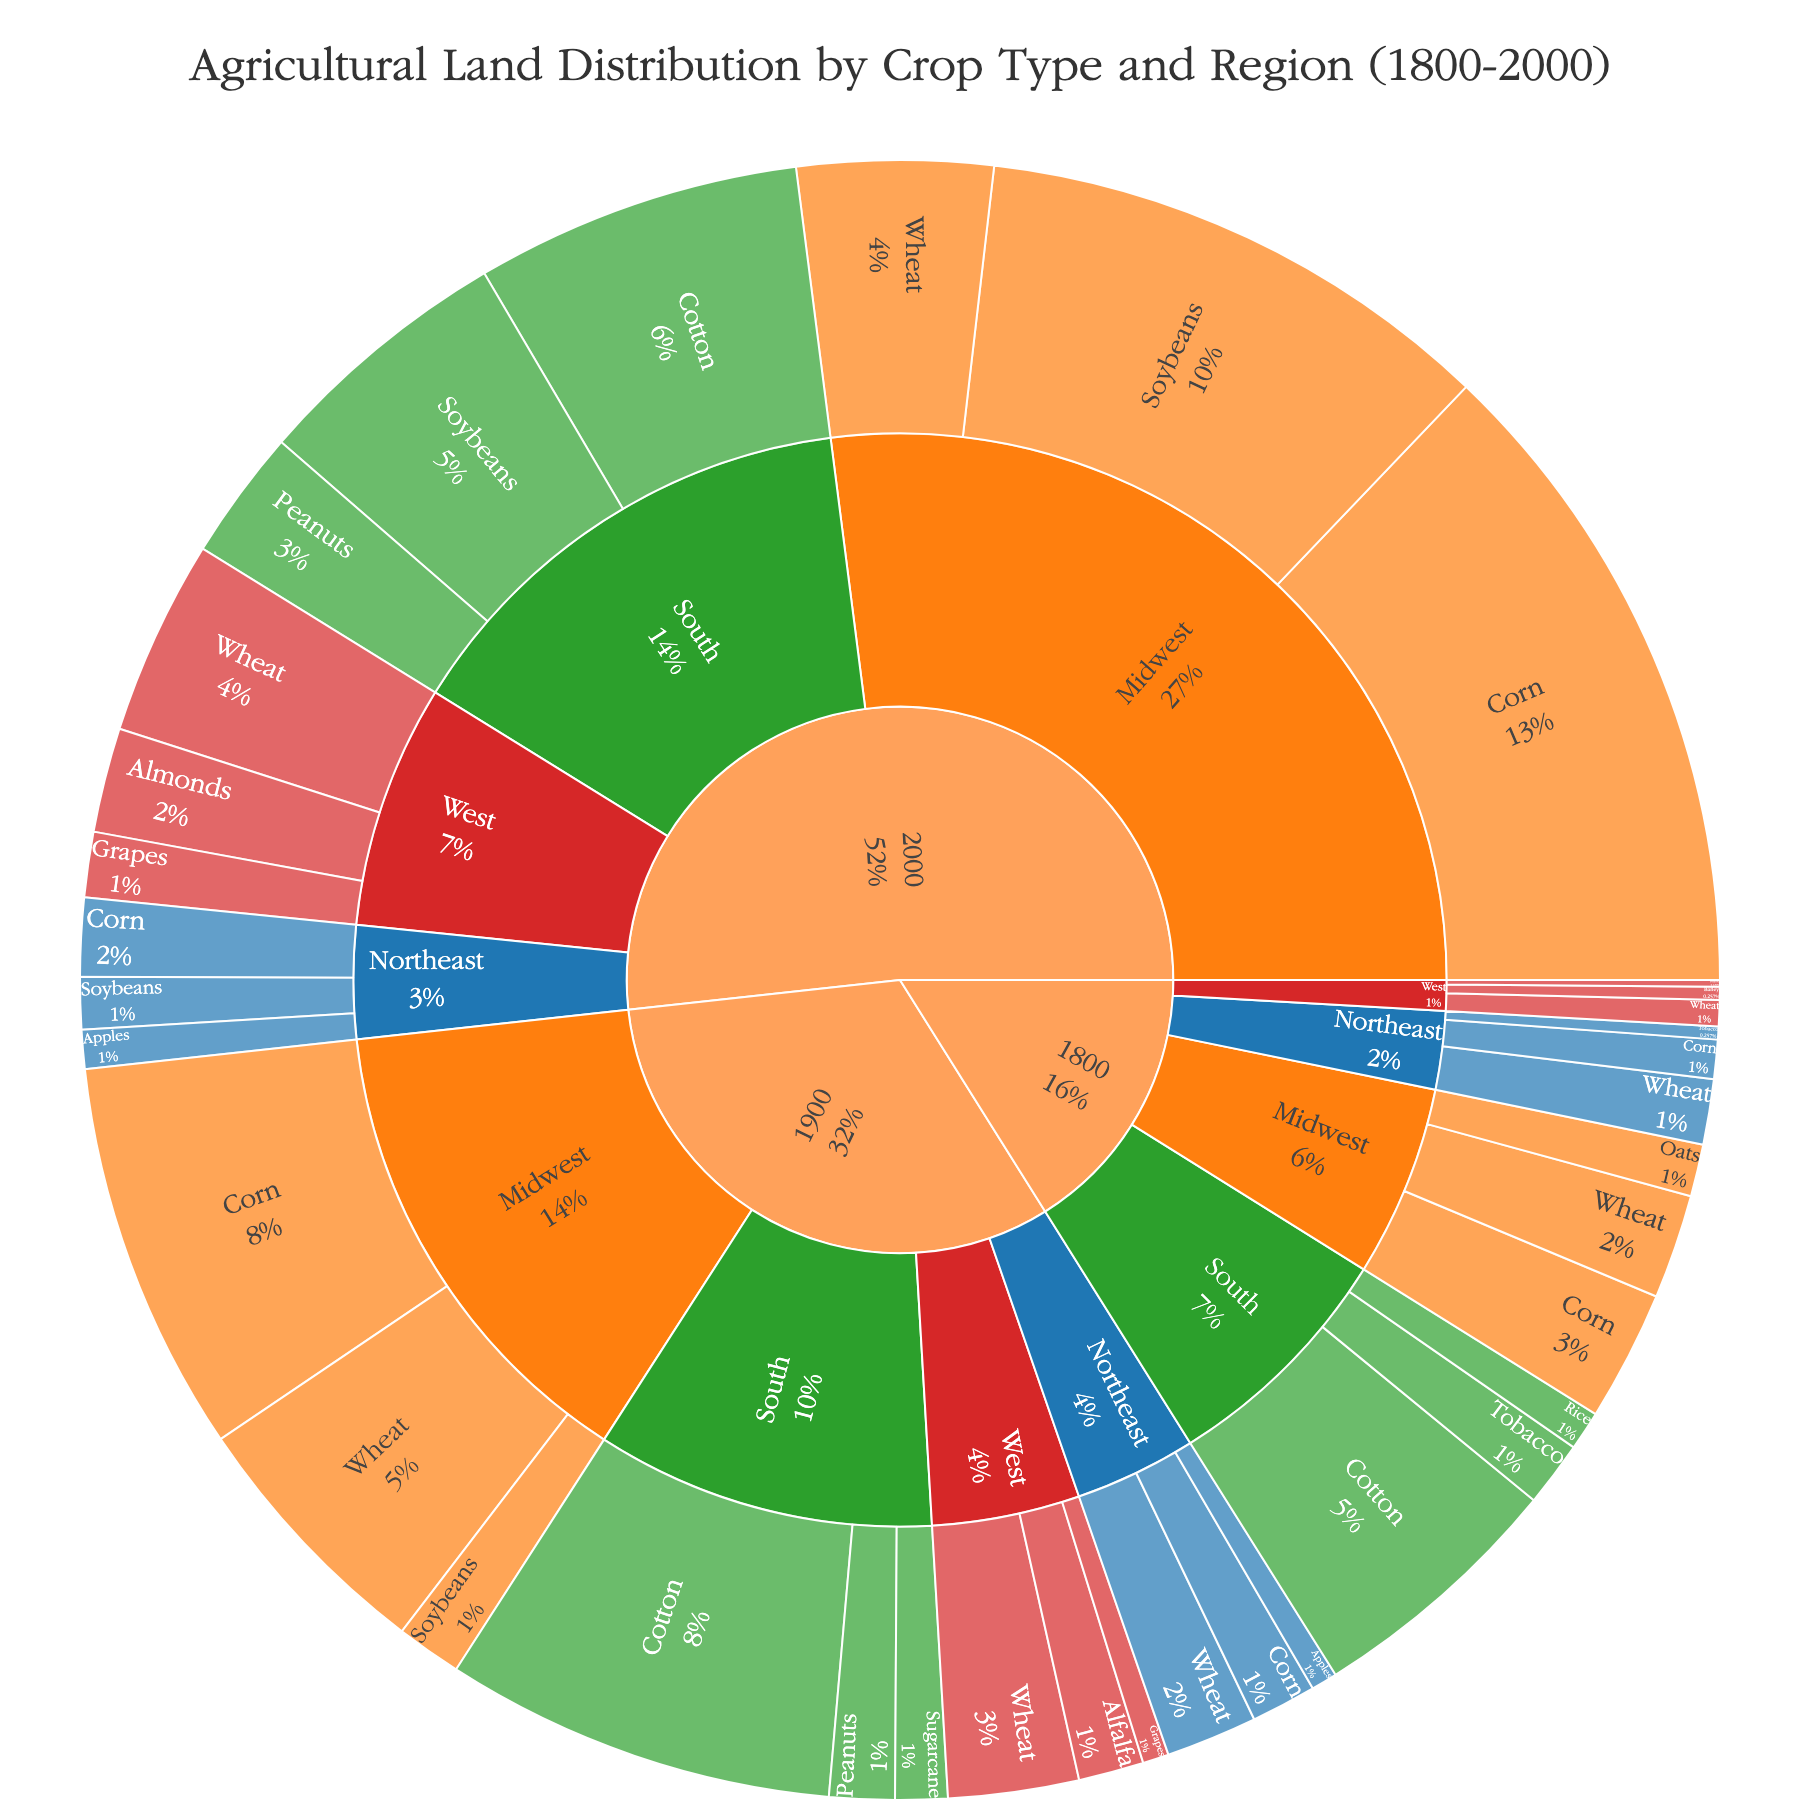What is the title of the figure? The title of the figure is usually presented at the top. In this case, it is "Agricultural Land Distribution by Crop Type and Region (1800-2000)."
Answer: Agricultural Land Distribution by Crop Type and Region (1800-2000) What colors are used to differentiate the regions? The regions are color-coded for distinction. Northeast is blue, Midwest is orange, South is green, and West is red.
Answer: Blue, Orange, Green, Red Which crop has the most significant increase in acreage in the Midwest from 1800 to 2000? To find the crop with the most significant increase, examine the acreage for each crop in the Midwest for 1800 and 2000. Corn goes from 1,000,000 acres in 1800 to 5,000,000 acres in 2000.
Answer: Corn In the year 1900, which region has the highest total acreage? Sum the acreages for each region in 1900. The South has Cotton (3,000,000), Peanuts (500,000), and Sugarcane (400,000), totaling 3,900,000 acres, which is the highest among the regions.
Answer: South Which region in the year 2000 has more acres dedicated to Soybeans? Compare the Soybeans acreage in 2000 across the regions. Midwest has 4,000,000 acres, South has 2,000,000 acres, and Northeast has 400,000 acres. The Midwest has the highest with 4,000,000 acres.
Answer: Midwest What is the total acreage of wheat in the West over all years? Sum the wheat acreages in the West for 1800 (200,000), 1900 (1,000,000), and 2000 (1,500,000), which totals 2,700,000 acres.
Answer: 2,700,000 acres Compare the acreage of Cotton in the South between 1800 and 2000. To compare, note Cotton in the South is 2,000,000 acres in 1800 and 2,500,000 acres in 2000. The acreage has increased by 500,000 acres.
Answer: 500,000 acres increase Which crop occupies the smallest acreage in the Northeast in 1900? Check the acreages for each crop in the Northeast in 1900: Wheat (700,000), Corn (500,000), and Apples (200,000). Apples occupy the smallest acreage.
Answer: Apples How does the land distribution for Corn in the Northeast change from 1800 to 2000? For Corn in the Northeast, the acreage changes from 300,000 in 1800 to 600,000 in 2000, indicating a doubling in land use for Corn.
Answer: Doubled Which year shows the greatest diversity in crop types across all regions? Look at the variety of crops in each year. In 2000, there are multiple crops in each region, showing the greatest diversity: Corn, Wheat, Soybeans, Apples, Almonds, Grapes, etc.
Answer: 2000 